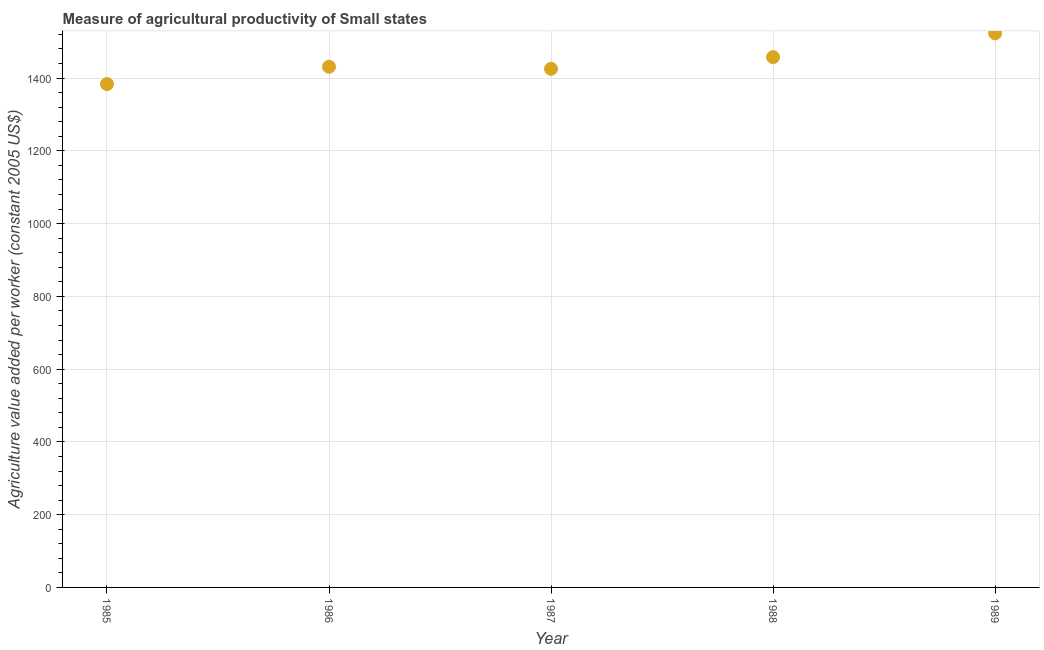What is the agriculture value added per worker in 1985?
Your response must be concise. 1383.41. Across all years, what is the maximum agriculture value added per worker?
Your response must be concise. 1522.92. Across all years, what is the minimum agriculture value added per worker?
Provide a short and direct response. 1383.41. In which year was the agriculture value added per worker maximum?
Keep it short and to the point. 1989. What is the sum of the agriculture value added per worker?
Offer a very short reply. 7220.57. What is the difference between the agriculture value added per worker in 1986 and 1988?
Give a very brief answer. -26.39. What is the average agriculture value added per worker per year?
Your response must be concise. 1444.11. What is the median agriculture value added per worker?
Make the answer very short. 1431.2. In how many years, is the agriculture value added per worker greater than 1120 US$?
Keep it short and to the point. 5. Do a majority of the years between 1987 and 1988 (inclusive) have agriculture value added per worker greater than 1200 US$?
Ensure brevity in your answer.  Yes. What is the ratio of the agriculture value added per worker in 1987 to that in 1989?
Provide a short and direct response. 0.94. Is the agriculture value added per worker in 1986 less than that in 1988?
Offer a very short reply. Yes. What is the difference between the highest and the second highest agriculture value added per worker?
Your response must be concise. 65.33. Is the sum of the agriculture value added per worker in 1987 and 1989 greater than the maximum agriculture value added per worker across all years?
Your answer should be compact. Yes. What is the difference between the highest and the lowest agriculture value added per worker?
Your answer should be very brief. 139.51. In how many years, is the agriculture value added per worker greater than the average agriculture value added per worker taken over all years?
Provide a succinct answer. 2. Does the agriculture value added per worker monotonically increase over the years?
Provide a short and direct response. No. How many dotlines are there?
Your answer should be very brief. 1. Are the values on the major ticks of Y-axis written in scientific E-notation?
Make the answer very short. No. Does the graph contain any zero values?
Give a very brief answer. No. What is the title of the graph?
Offer a terse response. Measure of agricultural productivity of Small states. What is the label or title of the Y-axis?
Your response must be concise. Agriculture value added per worker (constant 2005 US$). What is the Agriculture value added per worker (constant 2005 US$) in 1985?
Provide a succinct answer. 1383.41. What is the Agriculture value added per worker (constant 2005 US$) in 1986?
Your answer should be compact. 1431.2. What is the Agriculture value added per worker (constant 2005 US$) in 1987?
Provide a short and direct response. 1425.45. What is the Agriculture value added per worker (constant 2005 US$) in 1988?
Your answer should be compact. 1457.59. What is the Agriculture value added per worker (constant 2005 US$) in 1989?
Offer a very short reply. 1522.92. What is the difference between the Agriculture value added per worker (constant 2005 US$) in 1985 and 1986?
Make the answer very short. -47.79. What is the difference between the Agriculture value added per worker (constant 2005 US$) in 1985 and 1987?
Your answer should be compact. -42.03. What is the difference between the Agriculture value added per worker (constant 2005 US$) in 1985 and 1988?
Give a very brief answer. -74.17. What is the difference between the Agriculture value added per worker (constant 2005 US$) in 1985 and 1989?
Make the answer very short. -139.51. What is the difference between the Agriculture value added per worker (constant 2005 US$) in 1986 and 1987?
Your response must be concise. 5.75. What is the difference between the Agriculture value added per worker (constant 2005 US$) in 1986 and 1988?
Your response must be concise. -26.39. What is the difference between the Agriculture value added per worker (constant 2005 US$) in 1986 and 1989?
Offer a terse response. -91.72. What is the difference between the Agriculture value added per worker (constant 2005 US$) in 1987 and 1988?
Make the answer very short. -32.14. What is the difference between the Agriculture value added per worker (constant 2005 US$) in 1987 and 1989?
Ensure brevity in your answer.  -97.47. What is the difference between the Agriculture value added per worker (constant 2005 US$) in 1988 and 1989?
Give a very brief answer. -65.33. What is the ratio of the Agriculture value added per worker (constant 2005 US$) in 1985 to that in 1986?
Provide a succinct answer. 0.97. What is the ratio of the Agriculture value added per worker (constant 2005 US$) in 1985 to that in 1987?
Provide a succinct answer. 0.97. What is the ratio of the Agriculture value added per worker (constant 2005 US$) in 1985 to that in 1988?
Ensure brevity in your answer.  0.95. What is the ratio of the Agriculture value added per worker (constant 2005 US$) in 1985 to that in 1989?
Your answer should be very brief. 0.91. What is the ratio of the Agriculture value added per worker (constant 2005 US$) in 1987 to that in 1989?
Give a very brief answer. 0.94. What is the ratio of the Agriculture value added per worker (constant 2005 US$) in 1988 to that in 1989?
Offer a terse response. 0.96. 